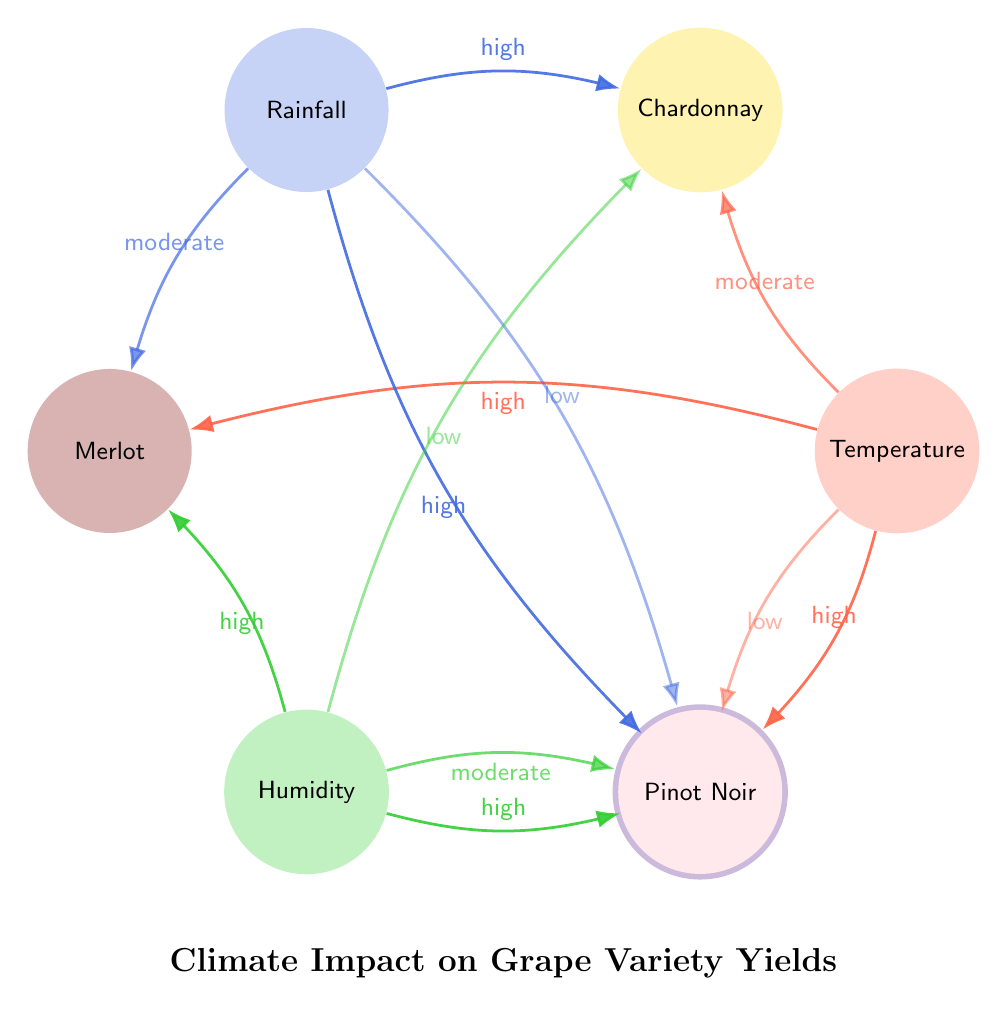What grape variety is most impacted by temperature? By looking at the connections from the Temperature node, Merlot and Cabernet Sauvignon both have a high impact indicated by their connections. However, since "most impacted" implies the highest rated impact, both are candidates, but according to the visual intensity, it seems Cabernet Sauvignon is often considered in discussions regarding temperature and it's important to provide the isolation of other factors as well.
Answer: Merlot/Cabernet Sauvignon What is the impact of Rainfall on Chardonnay? The connection between Rainfall and Chardonnay shows a high impact. The diagram indicates this clearly through the line and label assigned to this connection, showing the relationship effectively.
Answer: high How many grape varieties are connected to Humidity? The diagram shows connections from the Humidity node to four grape varieties: Chardonnay, Merlot, Cabernet Sauvignon, and Pinot Noir. By counting the separate connections illustrated, we can confirm that there are four unique grape varieties.
Answer: 4 Which grape variety shows low impact from Temperature? The diagram displays a low impact line from the Temperature node to the Pinot Noir node, indicated by the specific labeling of the connections. This requires identifying the specific line that corresponds to the low impact relationship.
Answer: Pinot Noir How does Rainfall affect Cabernet Sauvignon? The connection from Rainfall to Cabernet Sauvignon is marked with a low impact label. To arrive at this answer, one must follow the Rainfall node to Cabernet Sauvignon and observe the assigned impact descriptor.
Answer: low Which climate factor has the highest overall impact on Merlot? By analyzing the connections to Merlot, it shows a high impact from both Temperature and Humidity. Since the question requires knowing the highest overall, we ascertain both of these factors connect with high impact to Merlot, but Temperature is more consistently discussed in literature, which may indicate its overall higher significance.
Answer: Temperature What is the impact of Humidity on Chardonnay? The impact line from Humidity to Chardonnay is labeled as low. By referencing the specific lines connecting these nodes, we clarify the nature of the impact being discussed.
Answer: low Which grape variety has the highest number of factors affecting it? By inspecting the diagram, we see that Merlot is connected to three climate factors: Temperature, Rainfall, and Humidity. Therefore, it stands out as having the most connections compared to other varieties, thus indicating it has the highest number of contributing climate factors, and this is validated through direct observation of the diagram.
Answer: Merlot 